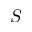Convert formula to latex. <formula><loc_0><loc_0><loc_500><loc_500>S</formula> 